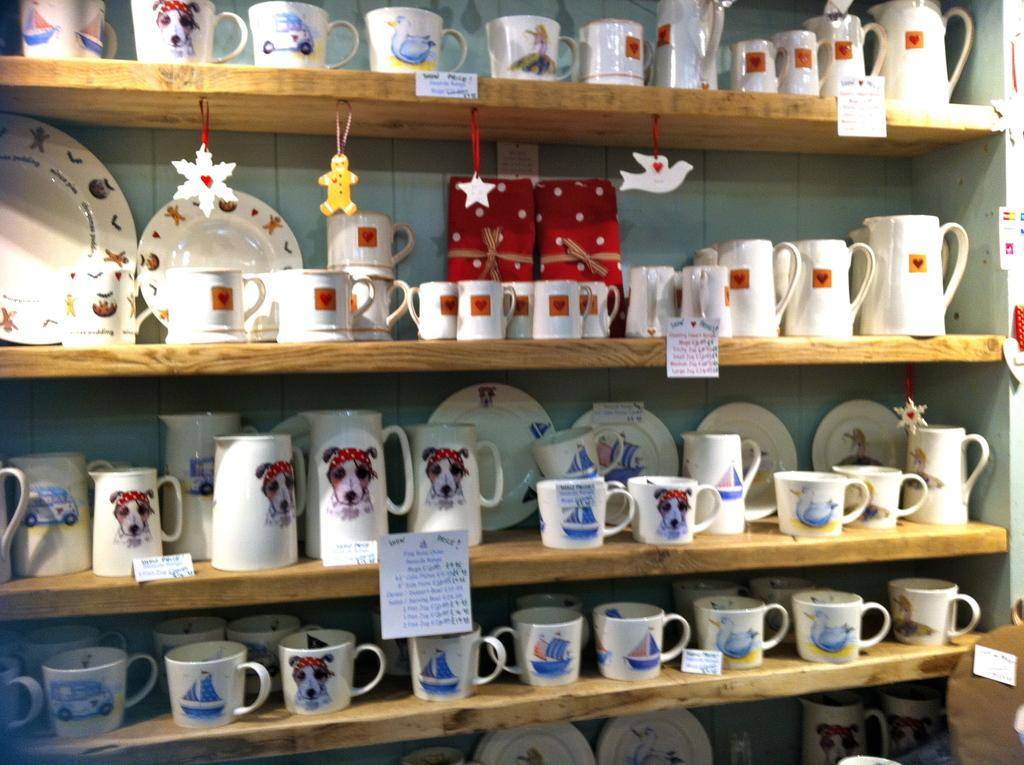What types of tableware are visible in the image? There are plates and cups in the image. What else can be seen on the shelves in the image? There is a jug and other things on the shelves in the image. What type of ray is visible in the image? There is no ray present in the image. Is this a party or a shop in the image? The image does not depict a party or a shop; it shows tableware and other items on shelves. 